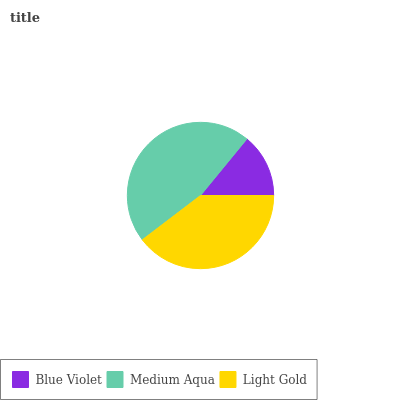Is Blue Violet the minimum?
Answer yes or no. Yes. Is Medium Aqua the maximum?
Answer yes or no. Yes. Is Light Gold the minimum?
Answer yes or no. No. Is Light Gold the maximum?
Answer yes or no. No. Is Medium Aqua greater than Light Gold?
Answer yes or no. Yes. Is Light Gold less than Medium Aqua?
Answer yes or no. Yes. Is Light Gold greater than Medium Aqua?
Answer yes or no. No. Is Medium Aqua less than Light Gold?
Answer yes or no. No. Is Light Gold the high median?
Answer yes or no. Yes. Is Light Gold the low median?
Answer yes or no. Yes. Is Medium Aqua the high median?
Answer yes or no. No. Is Blue Violet the low median?
Answer yes or no. No. 